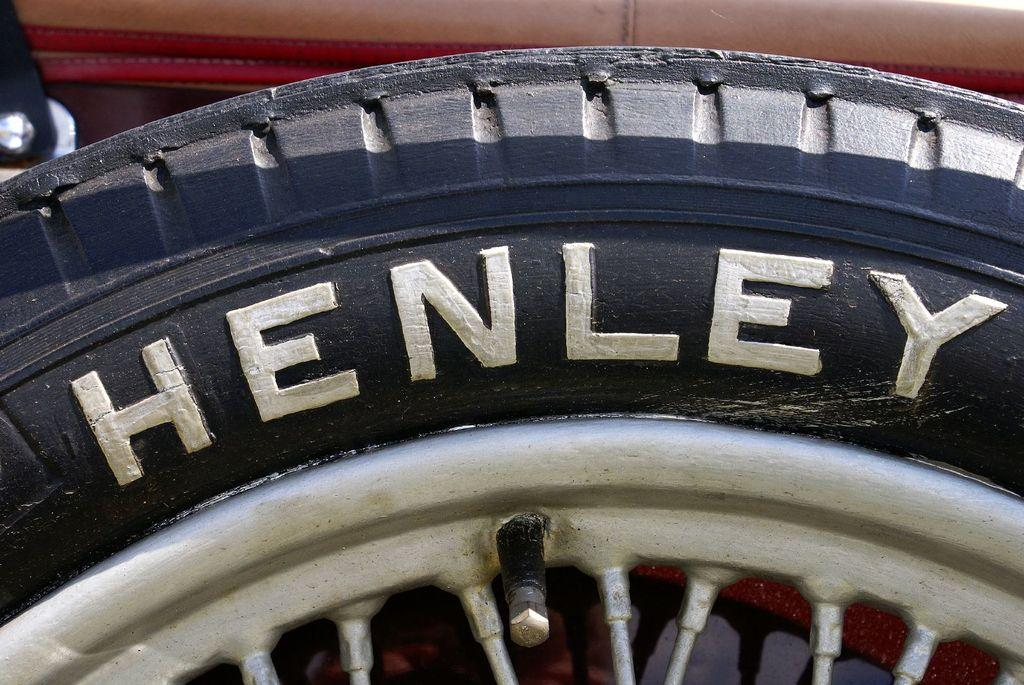What is the main object in the image? There is a vehicle tyre in the image. Can you describe the object in more detail? The object is a tyre used for vehicles, such as cars or trucks. What type of army equipment can be seen in the image? There is no army equipment present in the image; it only features a vehicle tyre. How does the knee of the person in the image look? There is no person present in the image, only a vehicle tyre. 